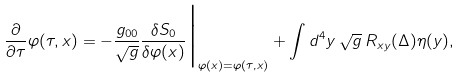Convert formula to latex. <formula><loc_0><loc_0><loc_500><loc_500>\frac { \partial } { \partial \tau } \varphi ( \tau , x ) = - \frac { g _ { 0 0 } } { \sqrt { g } } \frac { \delta S _ { 0 } } { \delta \varphi ( x ) } \Big | _ { \varphi ( x ) = \varphi ( \tau , x ) } + \int d ^ { 4 } y \, \sqrt { g } \, R _ { x y } ( \Delta ) \eta ( y ) ,</formula> 